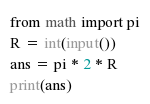Convert code to text. <code><loc_0><loc_0><loc_500><loc_500><_Python_>from math import pi
R = int(input())
ans = pi * 2 * R
print(ans)
</code> 